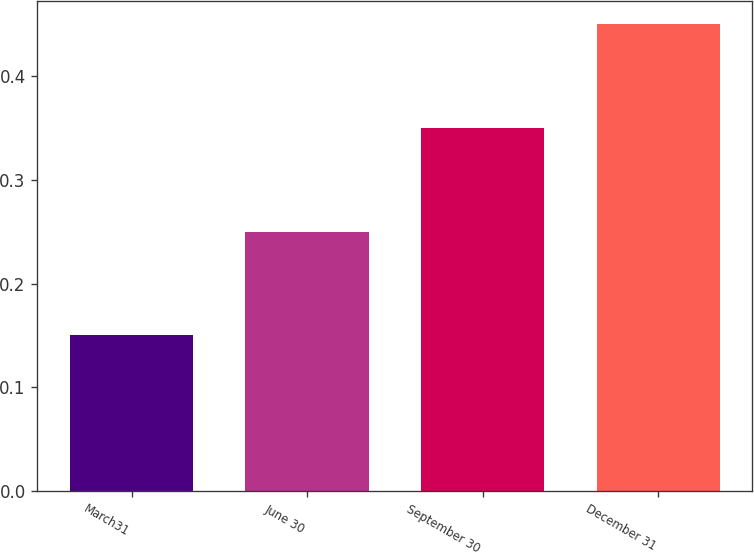<chart> <loc_0><loc_0><loc_500><loc_500><bar_chart><fcel>March31<fcel>June 30<fcel>September 30<fcel>December 31<nl><fcel>0.15<fcel>0.25<fcel>0.35<fcel>0.45<nl></chart> 